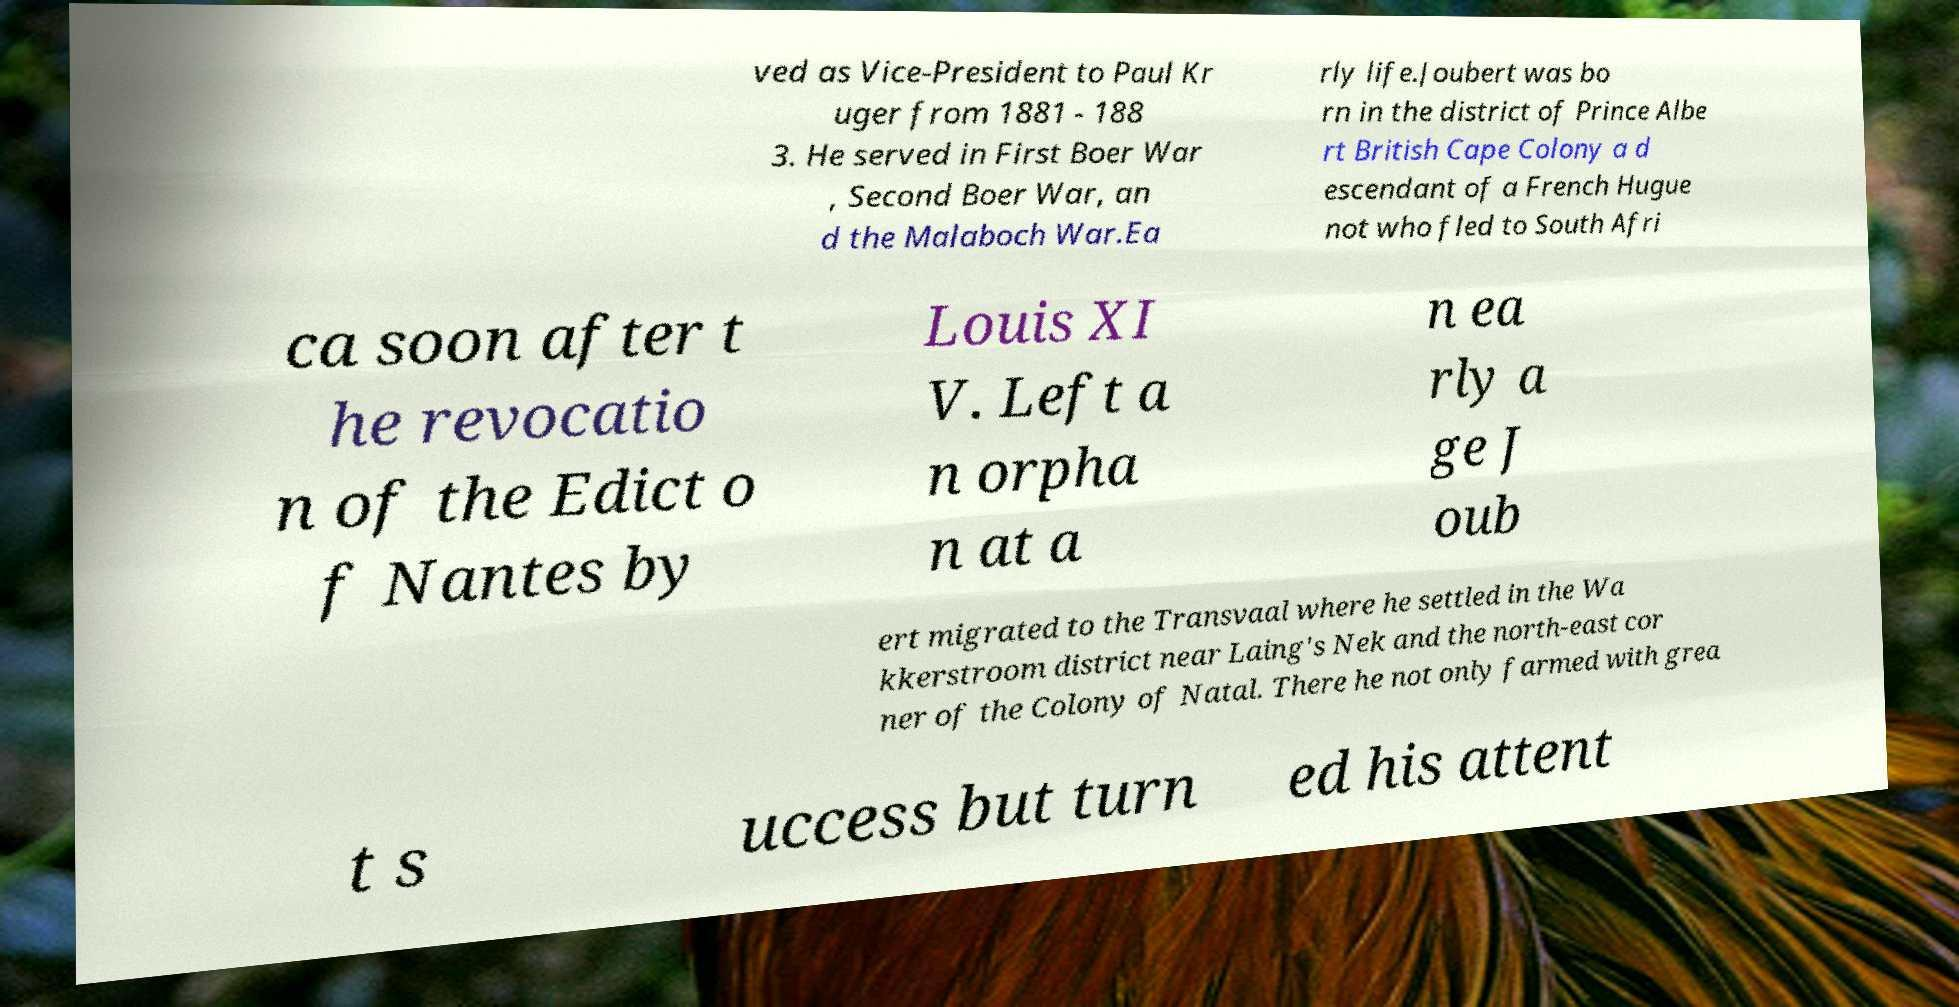Please read and relay the text visible in this image. What does it say? ved as Vice-President to Paul Kr uger from 1881 - 188 3. He served in First Boer War , Second Boer War, an d the Malaboch War.Ea rly life.Joubert was bo rn in the district of Prince Albe rt British Cape Colony a d escendant of a French Hugue not who fled to South Afri ca soon after t he revocatio n of the Edict o f Nantes by Louis XI V. Left a n orpha n at a n ea rly a ge J oub ert migrated to the Transvaal where he settled in the Wa kkerstroom district near Laing's Nek and the north-east cor ner of the Colony of Natal. There he not only farmed with grea t s uccess but turn ed his attent 